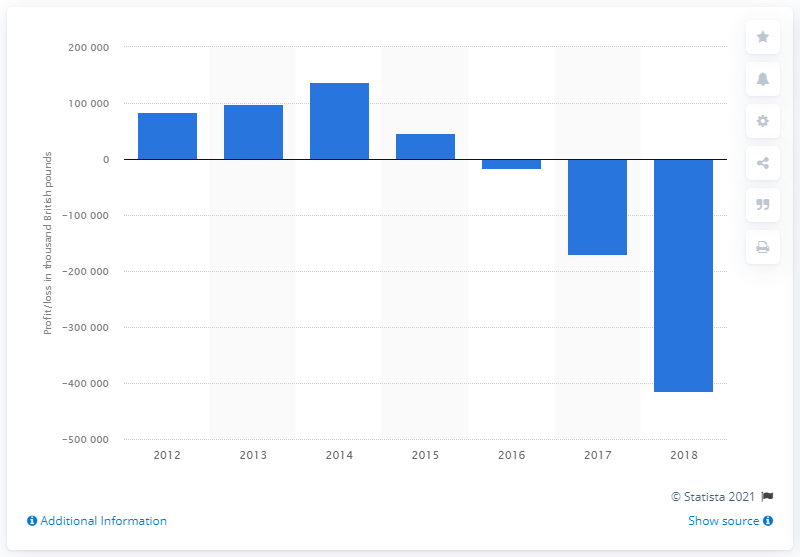Mention a couple of crucial points in this snapshot. In 2016, Amey UK plc recorded operating losses. 